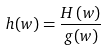Convert formula to latex. <formula><loc_0><loc_0><loc_500><loc_500>h ( w ) = \frac { H \left ( w \right ) } { g ( w ) }</formula> 